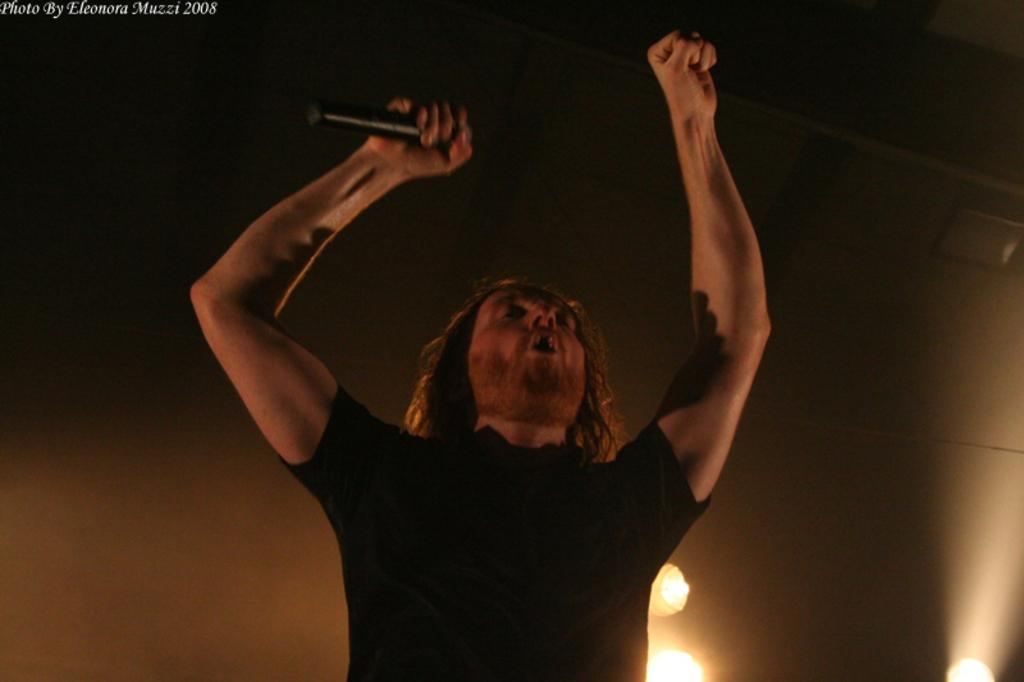What is the main subject of the image? There is a man in the image. What is the man wearing? The man is wearing a black t-shirt. What is the man holding in his hand? The man is holding a mic with one hand. What is the man doing with his other hand? The man is raising both his hands. What can be seen in the background of the image? There are lights in the background of the image. What type of religious ceremony is the man participating in, as depicted in the image? There is no indication of a religious ceremony in the image; the man is simply holding a mic and raising both his hands. Can you see any tools or equipment associated with carpentry in the image? No, there are no tools or equipment associated with carpentry visible in the image. 